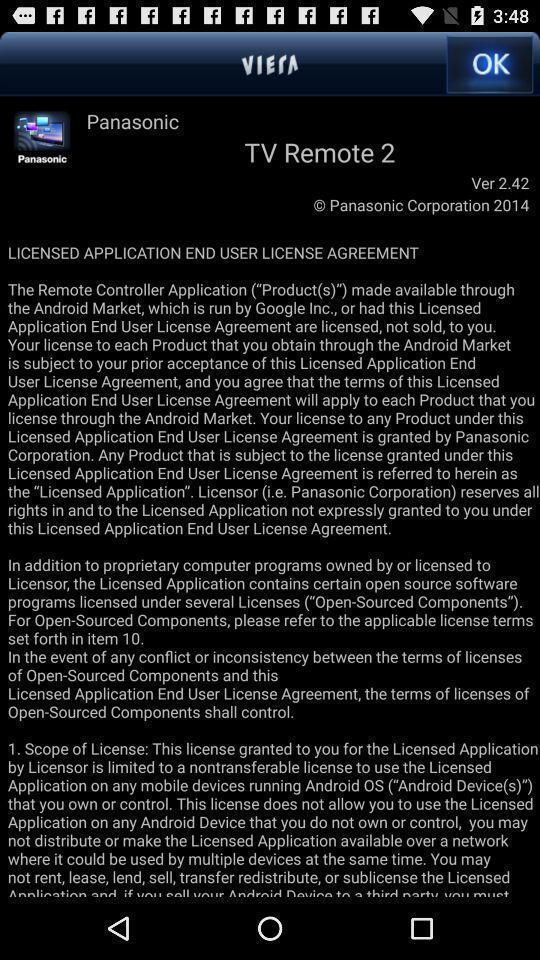Describe the visual elements of this screenshot. Screen showing the page of a tv app. 